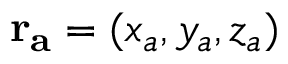Convert formula to latex. <formula><loc_0><loc_0><loc_500><loc_500>r _ { a } = ( x _ { a } , y _ { a } , z _ { a } )</formula> 